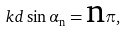<formula> <loc_0><loc_0><loc_500><loc_500>k d \sin \alpha { _ { \text {n} } } = \text {n} \pi ,</formula> 